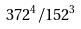Convert formula to latex. <formula><loc_0><loc_0><loc_500><loc_500>3 7 2 ^ { 4 } / 1 5 2 ^ { 3 }</formula> 